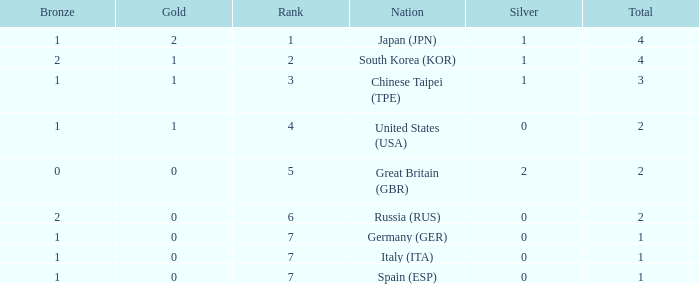How many total medals does a country with more than 1 silver medals have? 2.0. 